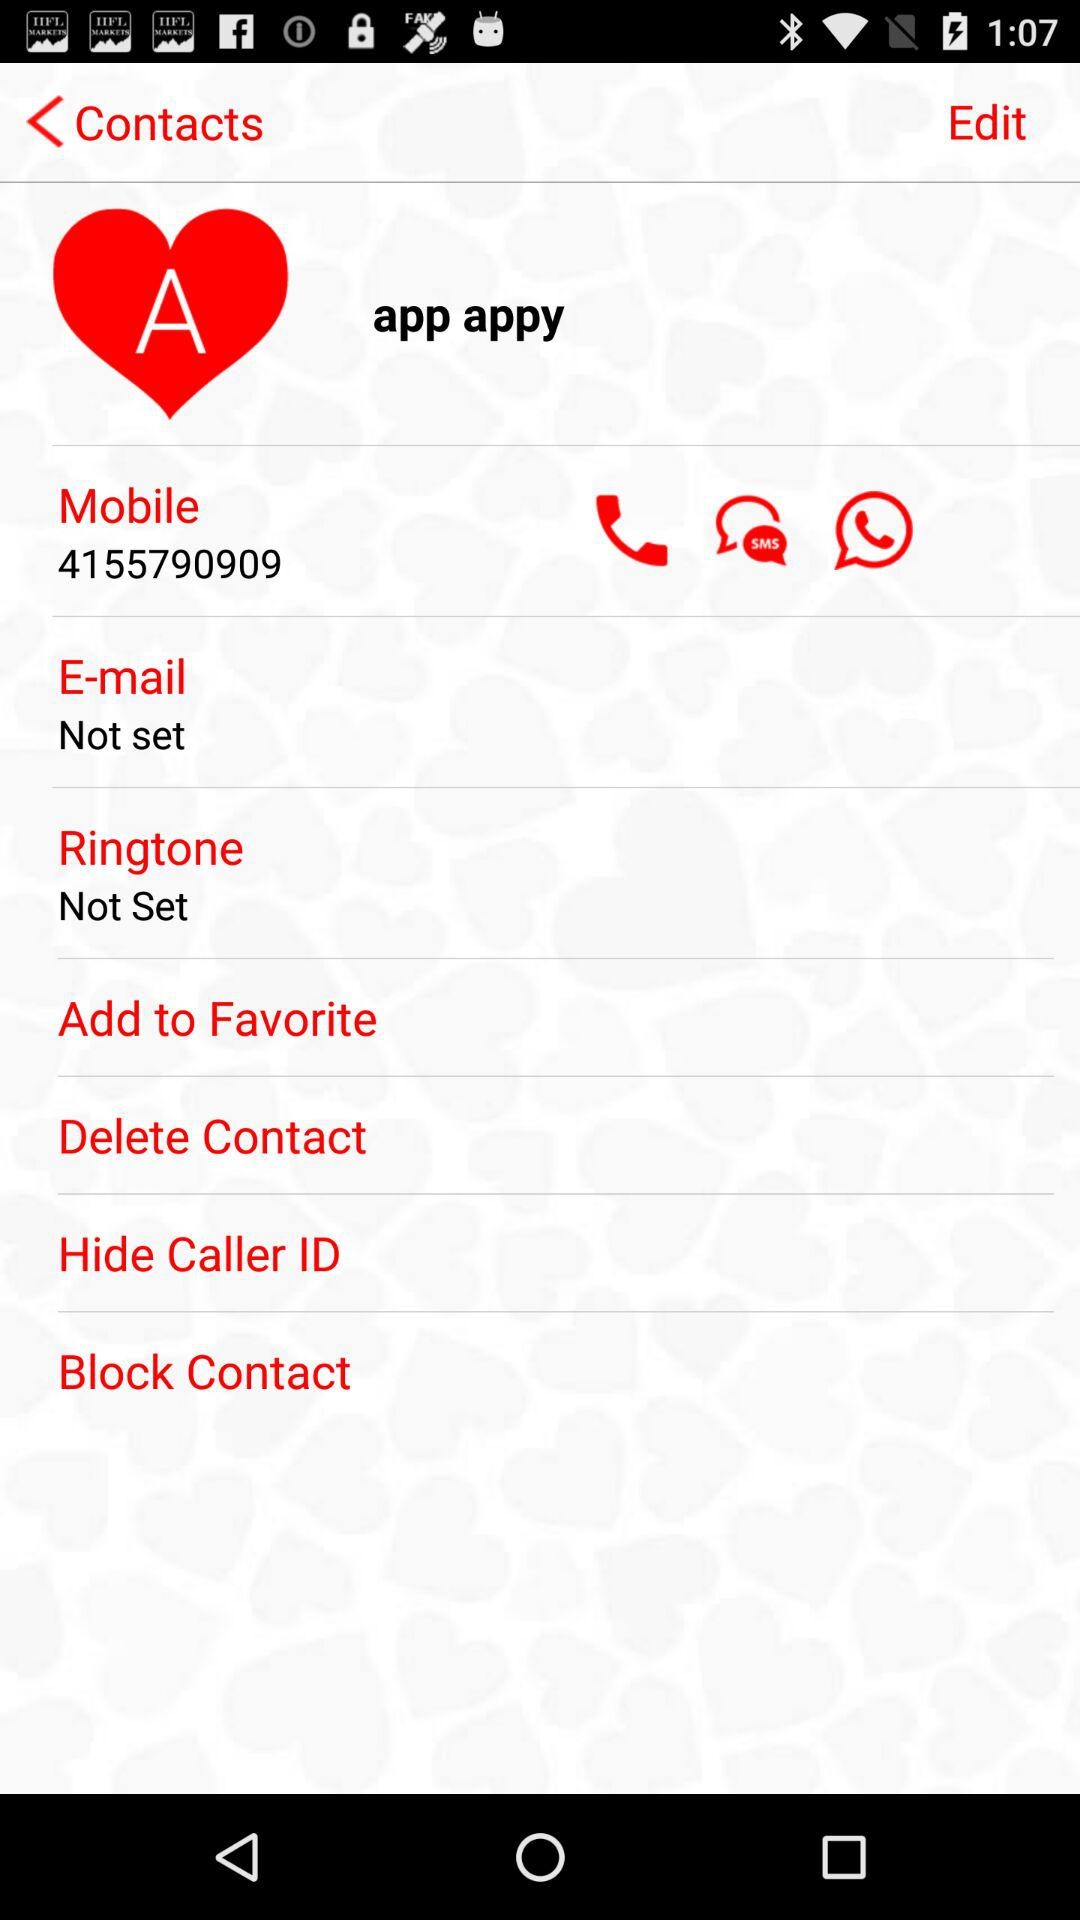What's the mobile number? The mobile number is 4155790909. 